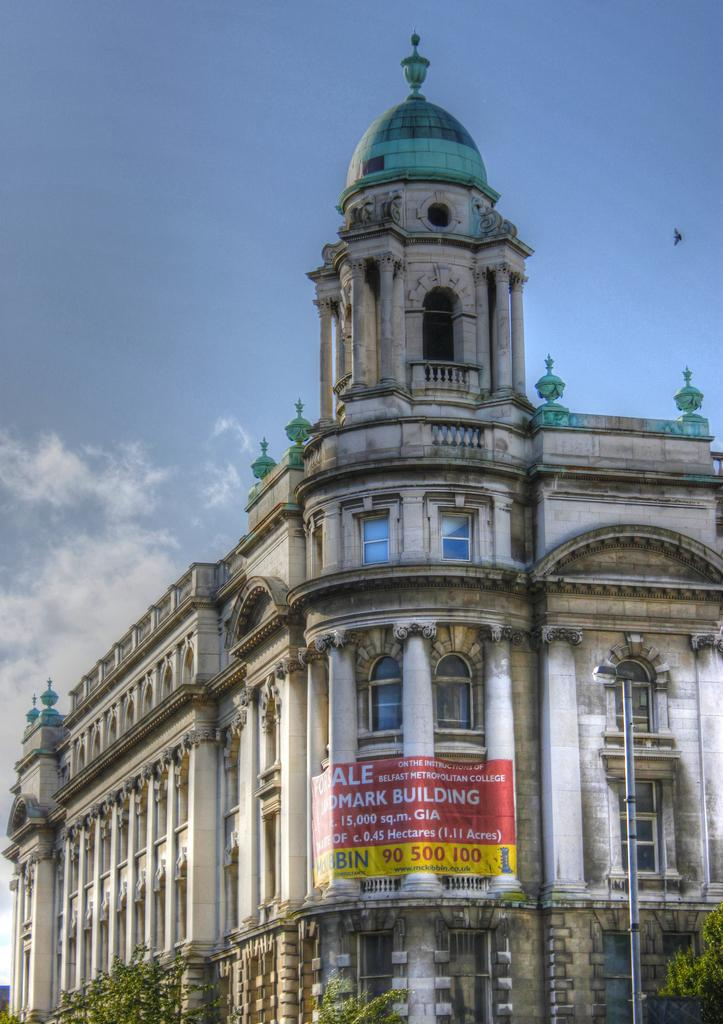What type of structure is present in the image? There is a building in the image. What is hanging from the building in the image? There is a banner in the image. What object is present near the building in the image? There is a pole in the image. What type of vegetation is visible in the image? There are trees in the image. What is visible in the sky at the top of the image? There are clouds visible in the sky at the top of the image. How many sheep are grazing in the image? There are no sheep present in the image. What hobbies do the people in the image have? There are no people present in the image, so their hobbies cannot be determined. 